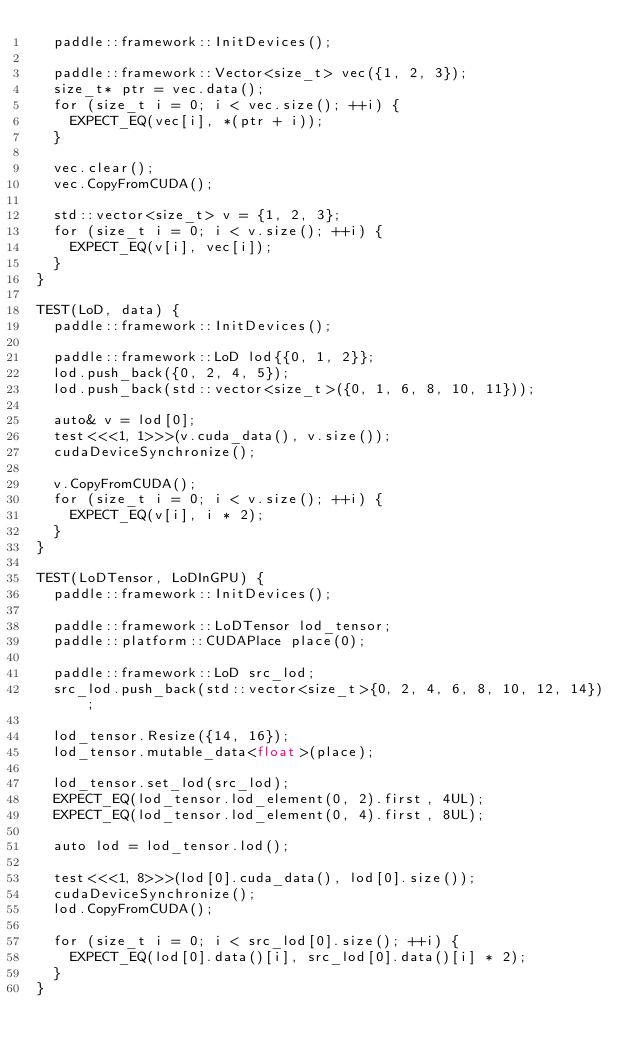Convert code to text. <code><loc_0><loc_0><loc_500><loc_500><_Cuda_>  paddle::framework::InitDevices();

  paddle::framework::Vector<size_t> vec({1, 2, 3});
  size_t* ptr = vec.data();
  for (size_t i = 0; i < vec.size(); ++i) {
    EXPECT_EQ(vec[i], *(ptr + i));
  }

  vec.clear();
  vec.CopyFromCUDA();

  std::vector<size_t> v = {1, 2, 3};
  for (size_t i = 0; i < v.size(); ++i) {
    EXPECT_EQ(v[i], vec[i]);
  }
}

TEST(LoD, data) {
  paddle::framework::InitDevices();

  paddle::framework::LoD lod{{0, 1, 2}};
  lod.push_back({0, 2, 4, 5});
  lod.push_back(std::vector<size_t>({0, 1, 6, 8, 10, 11}));

  auto& v = lod[0];
  test<<<1, 1>>>(v.cuda_data(), v.size());
  cudaDeviceSynchronize();

  v.CopyFromCUDA();
  for (size_t i = 0; i < v.size(); ++i) {
    EXPECT_EQ(v[i], i * 2);
  }
}

TEST(LoDTensor, LoDInGPU) {
  paddle::framework::InitDevices();

  paddle::framework::LoDTensor lod_tensor;
  paddle::platform::CUDAPlace place(0);

  paddle::framework::LoD src_lod;
  src_lod.push_back(std::vector<size_t>{0, 2, 4, 6, 8, 10, 12, 14});

  lod_tensor.Resize({14, 16});
  lod_tensor.mutable_data<float>(place);

  lod_tensor.set_lod(src_lod);
  EXPECT_EQ(lod_tensor.lod_element(0, 2).first, 4UL);
  EXPECT_EQ(lod_tensor.lod_element(0, 4).first, 8UL);

  auto lod = lod_tensor.lod();

  test<<<1, 8>>>(lod[0].cuda_data(), lod[0].size());
  cudaDeviceSynchronize();
  lod.CopyFromCUDA();

  for (size_t i = 0; i < src_lod[0].size(); ++i) {
    EXPECT_EQ(lod[0].data()[i], src_lod[0].data()[i] * 2);
  }
}
</code> 